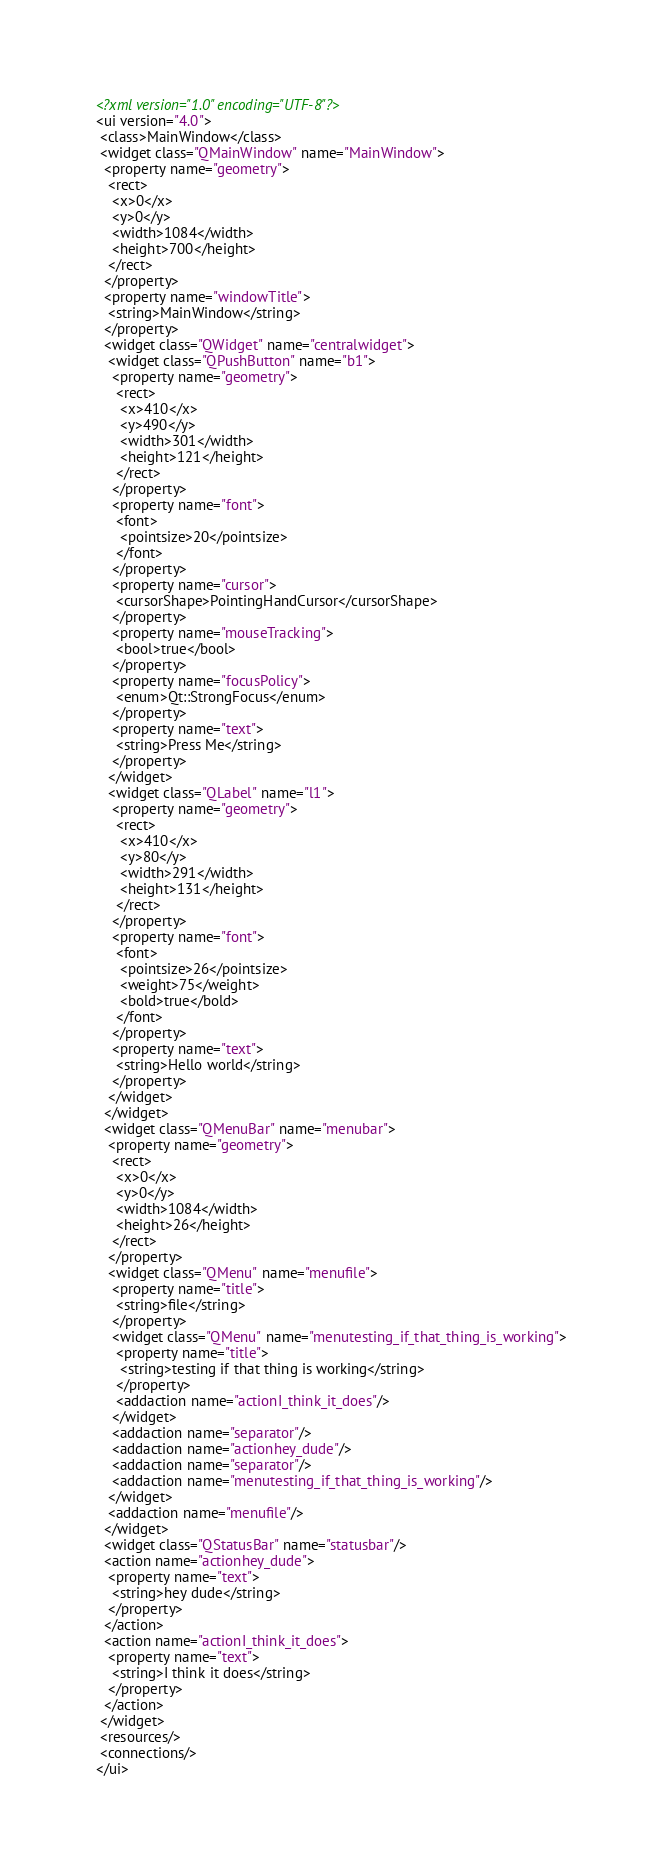<code> <loc_0><loc_0><loc_500><loc_500><_XML_><?xml version="1.0" encoding="UTF-8"?>
<ui version="4.0">
 <class>MainWindow</class>
 <widget class="QMainWindow" name="MainWindow">
  <property name="geometry">
   <rect>
    <x>0</x>
    <y>0</y>
    <width>1084</width>
    <height>700</height>
   </rect>
  </property>
  <property name="windowTitle">
   <string>MainWindow</string>
  </property>
  <widget class="QWidget" name="centralwidget">
   <widget class="QPushButton" name="b1">
    <property name="geometry">
     <rect>
      <x>410</x>
      <y>490</y>
      <width>301</width>
      <height>121</height>
     </rect>
    </property>
    <property name="font">
     <font>
      <pointsize>20</pointsize>
     </font>
    </property>
    <property name="cursor">
     <cursorShape>PointingHandCursor</cursorShape>
    </property>
    <property name="mouseTracking">
     <bool>true</bool>
    </property>
    <property name="focusPolicy">
     <enum>Qt::StrongFocus</enum>
    </property>
    <property name="text">
     <string>Press Me</string>
    </property>
   </widget>
   <widget class="QLabel" name="l1">
    <property name="geometry">
     <rect>
      <x>410</x>
      <y>80</y>
      <width>291</width>
      <height>131</height>
     </rect>
    </property>
    <property name="font">
     <font>
      <pointsize>26</pointsize>
      <weight>75</weight>
      <bold>true</bold>
     </font>
    </property>
    <property name="text">
     <string>Hello world</string>
    </property>
   </widget>
  </widget>
  <widget class="QMenuBar" name="menubar">
   <property name="geometry">
    <rect>
     <x>0</x>
     <y>0</y>
     <width>1084</width>
     <height>26</height>
    </rect>
   </property>
   <widget class="QMenu" name="menufile">
    <property name="title">
     <string>file</string>
    </property>
    <widget class="QMenu" name="menutesting_if_that_thing_is_working">
     <property name="title">
      <string>testing if that thing is working</string>
     </property>
     <addaction name="actionI_think_it_does"/>
    </widget>
    <addaction name="separator"/>
    <addaction name="actionhey_dude"/>
    <addaction name="separator"/>
    <addaction name="menutesting_if_that_thing_is_working"/>
   </widget>
   <addaction name="menufile"/>
  </widget>
  <widget class="QStatusBar" name="statusbar"/>
  <action name="actionhey_dude">
   <property name="text">
    <string>hey dude</string>
   </property>
  </action>
  <action name="actionI_think_it_does">
   <property name="text">
    <string>I think it does</string>
   </property>
  </action>
 </widget>
 <resources/>
 <connections/>
</ui>
</code> 